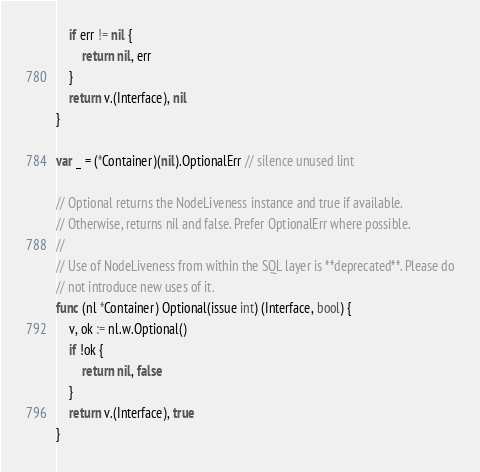<code> <loc_0><loc_0><loc_500><loc_500><_Go_>	if err != nil {
		return nil, err
	}
	return v.(Interface), nil
}

var _ = (*Container)(nil).OptionalErr // silence unused lint

// Optional returns the NodeLiveness instance and true if available.
// Otherwise, returns nil and false. Prefer OptionalErr where possible.
//
// Use of NodeLiveness from within the SQL layer is **deprecated**. Please do
// not introduce new uses of it.
func (nl *Container) Optional(issue int) (Interface, bool) {
	v, ok := nl.w.Optional()
	if !ok {
		return nil, false
	}
	return v.(Interface), true
}
</code> 